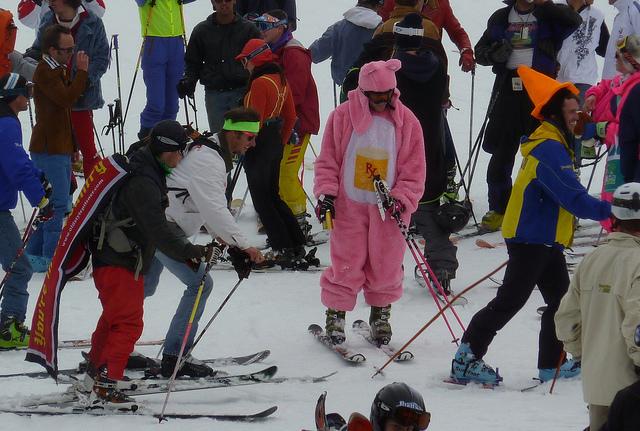What does the man on the right have on his head?
Write a very short answer. Cone. What stands out about the man in the middle?
Concise answer only. Pink bunny suit. Is this a 4th of July parade?
Short answer required. No. What are the people doing?
Write a very short answer. Skiing. 